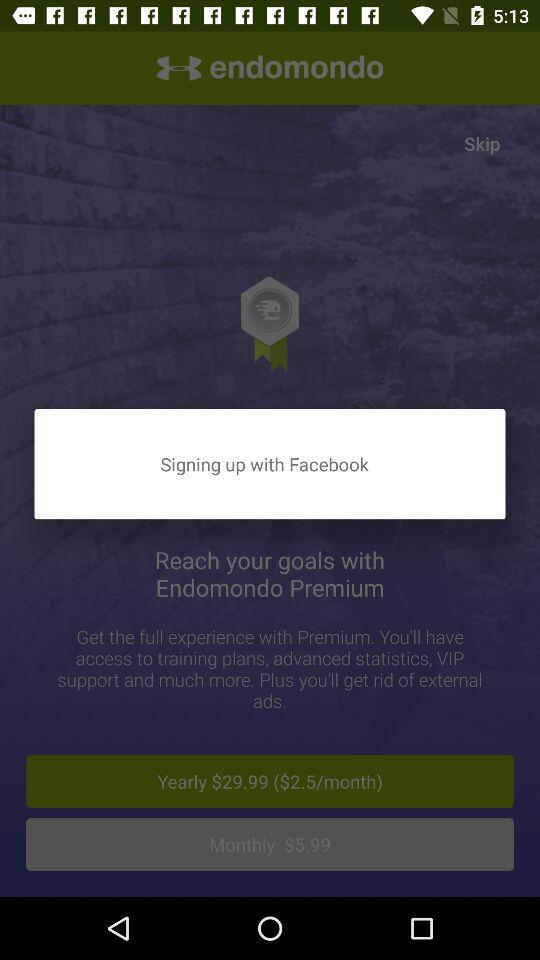How much is the monthly subscription for Endomondo Premium?
Answer the question using a single word or phrase. $5.99 